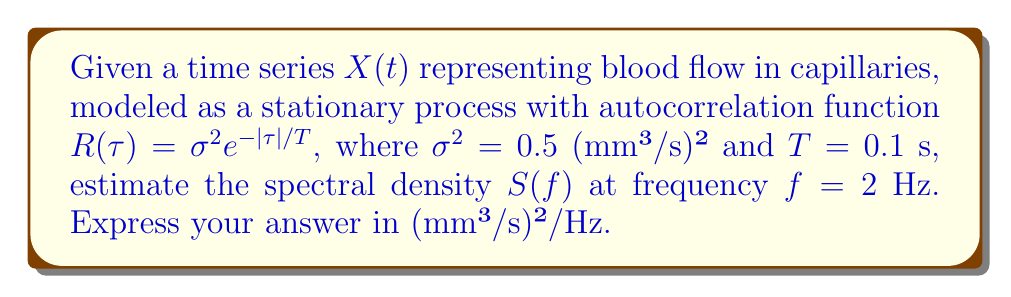Can you solve this math problem? To estimate the spectral density, we'll follow these steps:

1) For a stationary process, the spectral density $S(f)$ is the Fourier transform of the autocorrelation function $R(\tau)$:

   $$S(f) = \int_{-\infty}^{\infty} R(\tau) e^{-i2\pi f\tau} d\tau$$

2) Given $R(\tau) = \sigma^2 e^{-|\tau|/T}$, we can split the integral:

   $$S(f) = \int_{0}^{\infty} \sigma^2 e^{-\tau/T} e^{-i2\pi f\tau} d\tau + \int_{-\infty}^{0} \sigma^2 e^{\tau/T} e^{-i2\pi f\tau} d\tau$$

3) Solving these integrals:

   $$S(f) = \sigma^2 T \left(\frac{1}{1/T + i2\pi f} + \frac{1}{1/T - i2\pi f}\right)$$

4) Simplifying:

   $$S(f) = \frac{2\sigma^2 T}{1 + (2\pi fT)^2}$$

5) Substituting the given values: $\sigma^2 = 0.5$ (mm³/s)², $T = 0.1$ s, and $f = 2$ Hz:

   $$S(2) = \frac{2 \cdot 0.5 \cdot 0.1}{1 + (2\pi \cdot 2 \cdot 0.1)^2} \approx 0.0126$$

6) The units are (mm³/s)²/Hz.
Answer: 0.0126 (mm³/s)²/Hz 